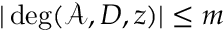Convert formula to latex. <formula><loc_0><loc_0><loc_500><loc_500>| \deg ( \mathcal { A } , D , z ) | \leq m</formula> 